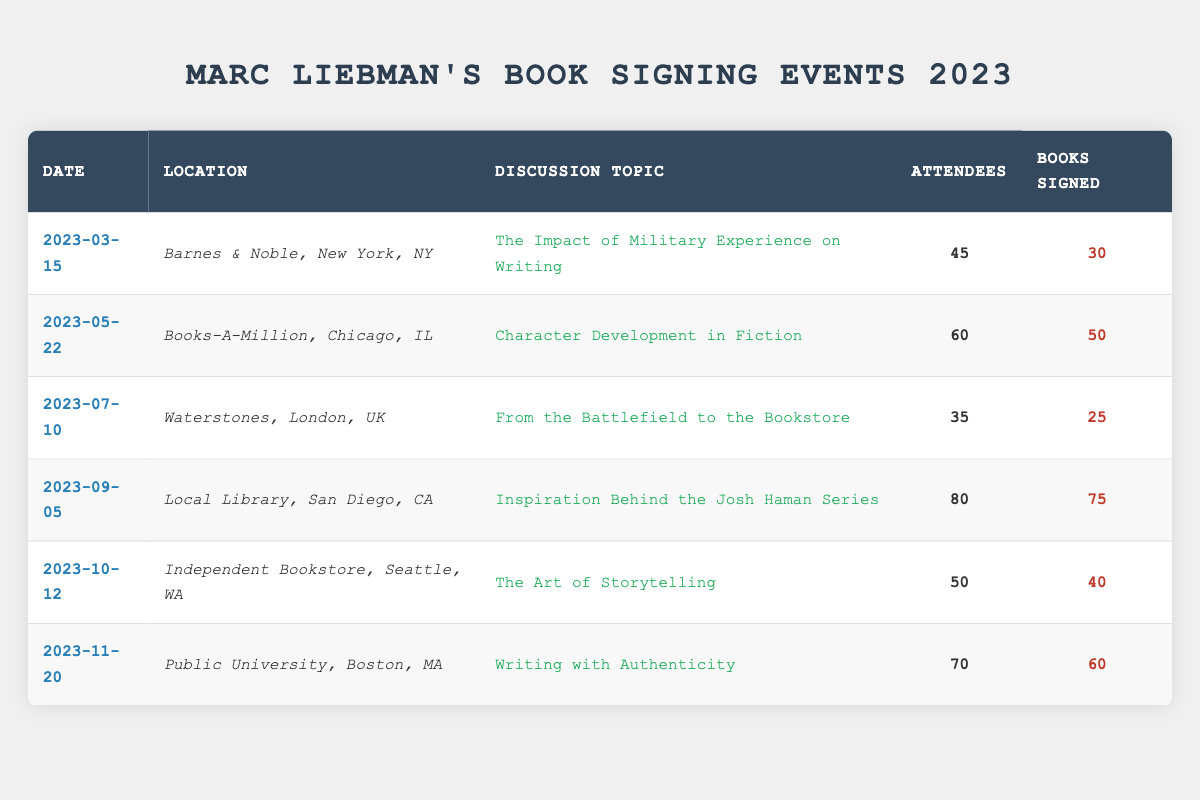What was the highest number of attendees at the events? The events with the highest number of attendees are listed in the table. Looking through the "Attendees" column, the maximum value is 80, which corresponds to the event on September 5, 2023.
Answer: 80 What is the total number of books signed across all events? To find the total number of books signed, sum all the values in the "Books Signed" column: 30 + 50 + 25 + 75 + 40 + 60 = 280.
Answer: 280 Was there an event held in Chicago? Yes, there is an event listed under "Location" with Chicago. The event on May 22, 2023, took place at Books-A-Million in Chicago, IL.
Answer: Yes Which discussion topic had the least number of attendees? The event with the least attendees is on July 10, 2023, at Waterstones in London, UK, with only 35 attendees listed under the "Attendees" column.
Answer: The Impact of Military Experience on Writing What is the average number of books signed per event? To calculate the average, first sum the number of books signed: 30 + 50 + 25 + 75 + 40 + 60 = 280. There are 6 events, so divide the total by 6: 280 / 6 ≈ 46.67. Therefore, the average is approximately 46.67 books signed per event.
Answer: 46.67 How many events were held on dates in the second half of the year? The table lists events from March to November 2023. Checking the "Event Date" column, the events on September 5, October 12, and November 20 fall into the second half of the year, totaling 3 events.
Answer: 3 What event had the highest number of books signed, and how many were signed? Looking at the "Books Signed" column, the highest number is 75, which corresponds to the event on September 5, 2023, at the Local Library in San Diego, CA.
Answer: Inspiration Behind the Josh Haman Series, 75 Was there an event discussing "Character Development in Fiction"? Yes, the event on May 22, 2023, had a discussion topic on "Character Development in Fiction," attended by 60 people.
Answer: Yes Which event had the most books signed relative to the number of attendees? To find the ratio of books signed to attendees for each event: March (30/45 = 0.67), May (50/60 = 0.83), July (25/35 = 0.71), September (75/80 = 0.94), October (40/50 = 0.80), November (60/70 = 0.86). The highest ratio is for the event on September 5, 2023, with a ratio of 0.94.
Answer: September 5, 2023 